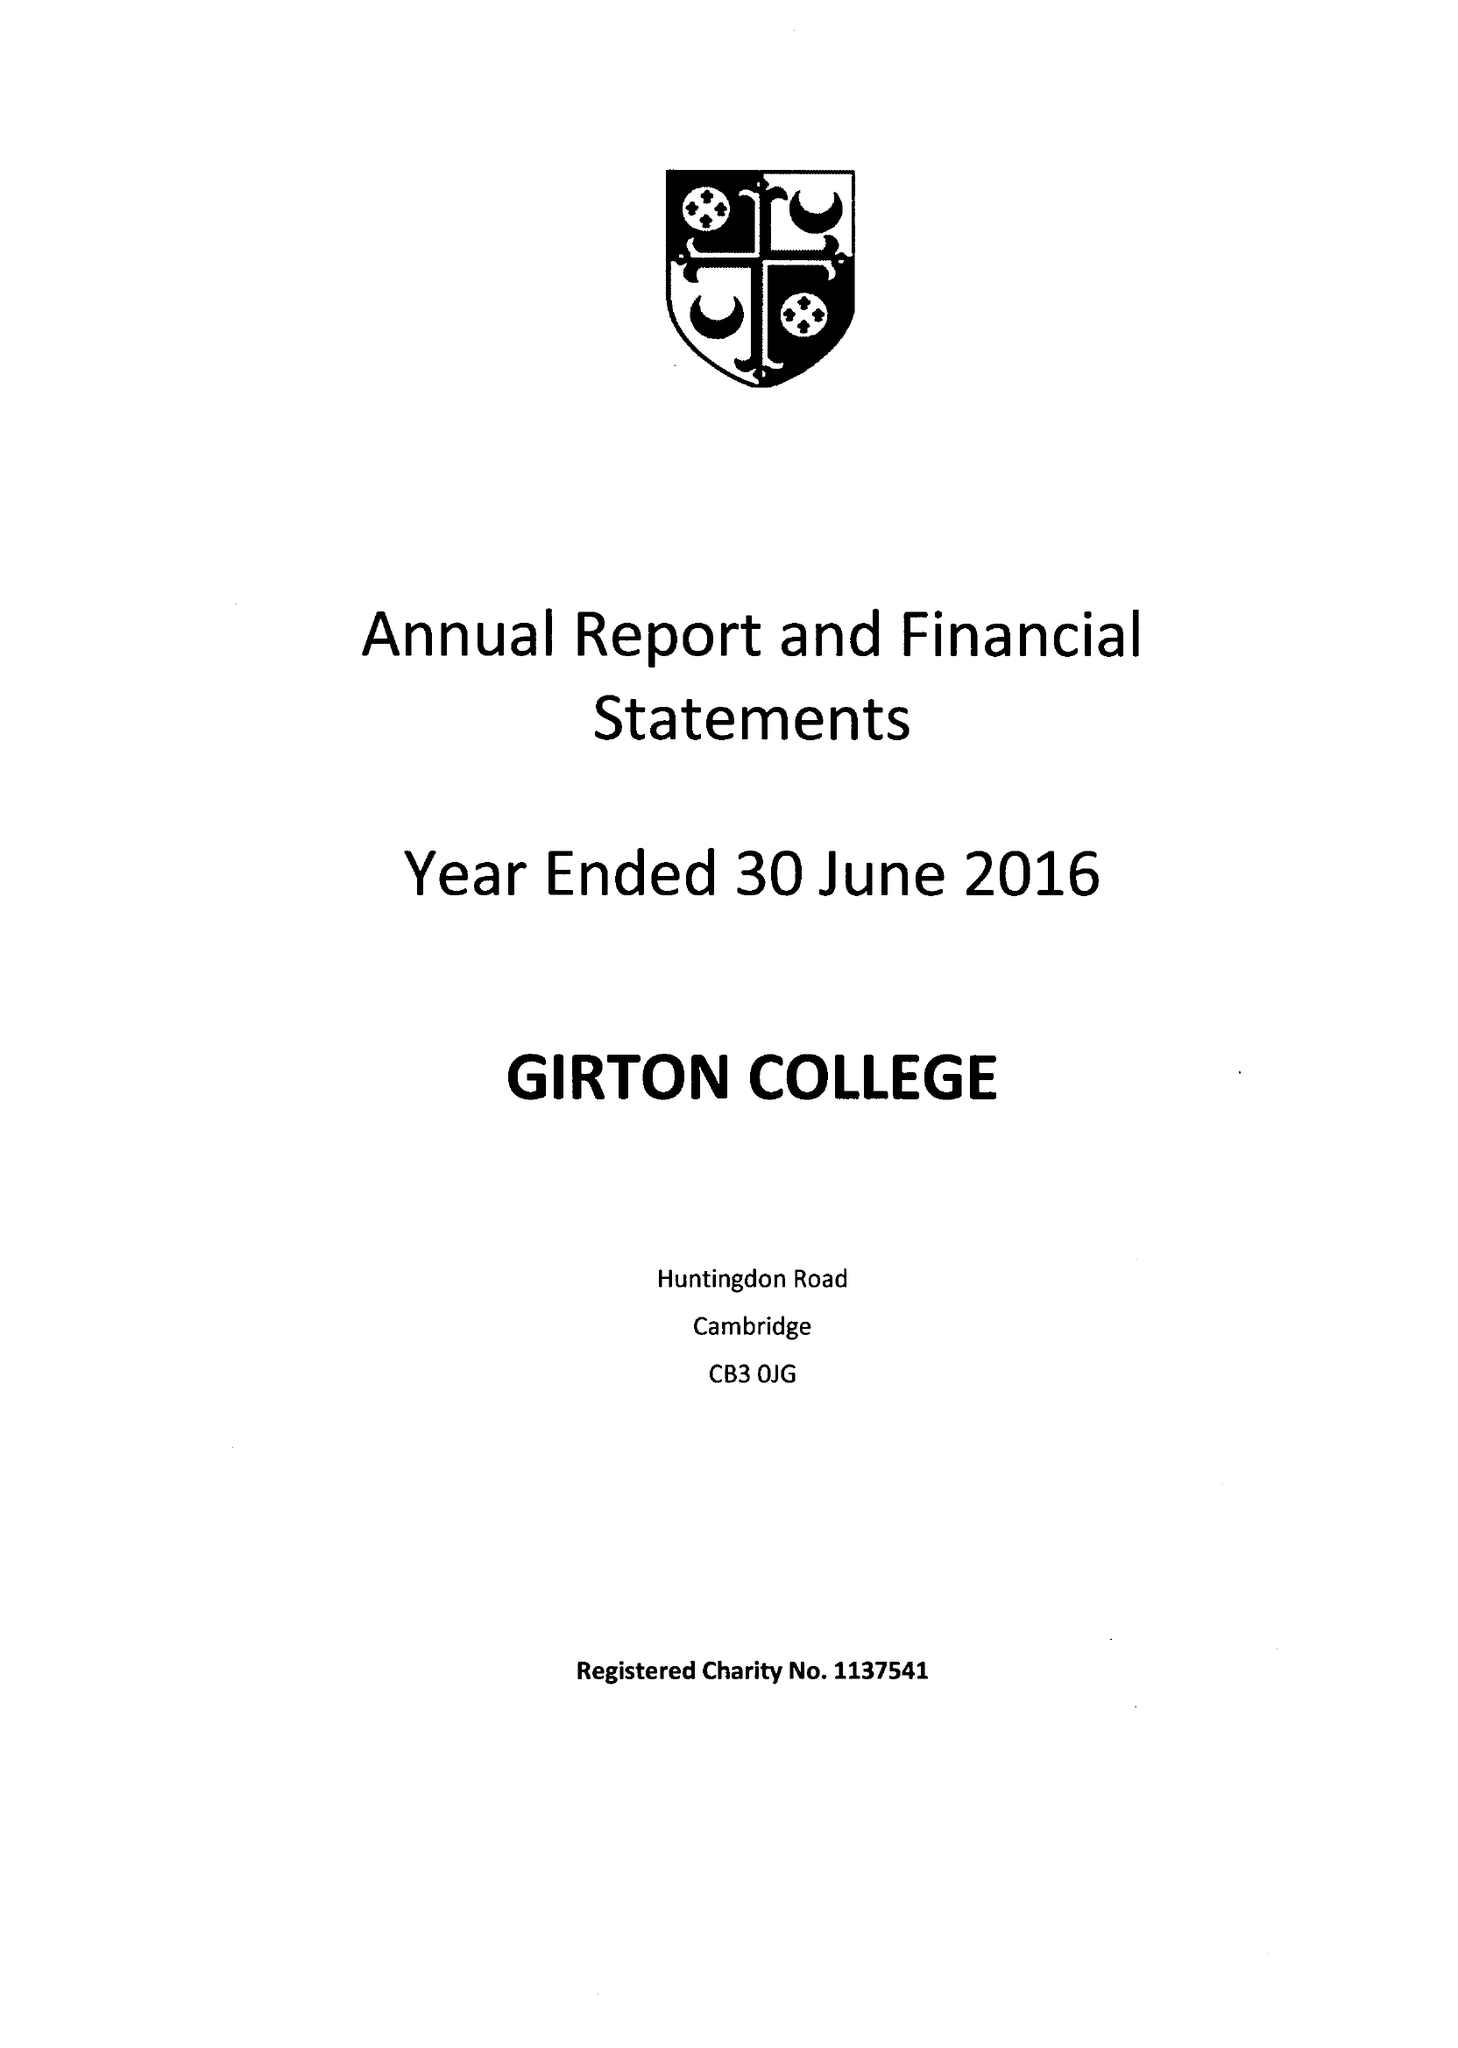What is the value for the address__street_line?
Answer the question using a single word or phrase. HUNTINGDON ROAD 